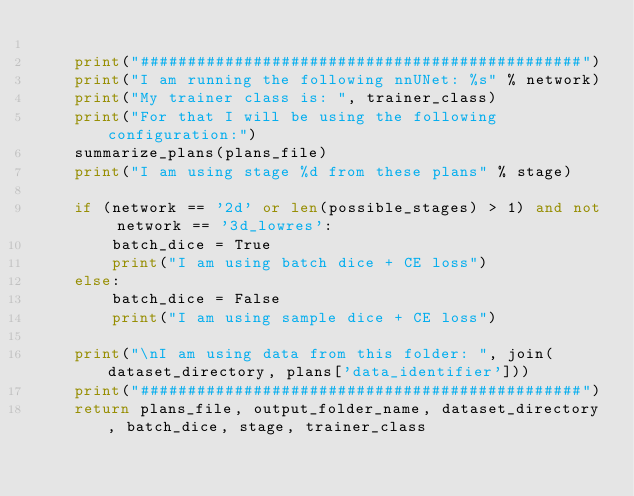<code> <loc_0><loc_0><loc_500><loc_500><_Python_>
    print("###############################################")
    print("I am running the following nnUNet: %s" % network)
    print("My trainer class is: ", trainer_class)
    print("For that I will be using the following configuration:")
    summarize_plans(plans_file)
    print("I am using stage %d from these plans" % stage)

    if (network == '2d' or len(possible_stages) > 1) and not network == '3d_lowres':
        batch_dice = True
        print("I am using batch dice + CE loss")
    else:
        batch_dice = False
        print("I am using sample dice + CE loss")

    print("\nI am using data from this folder: ", join(dataset_directory, plans['data_identifier']))
    print("###############################################")
    return plans_file, output_folder_name, dataset_directory, batch_dice, stage, trainer_class
</code> 